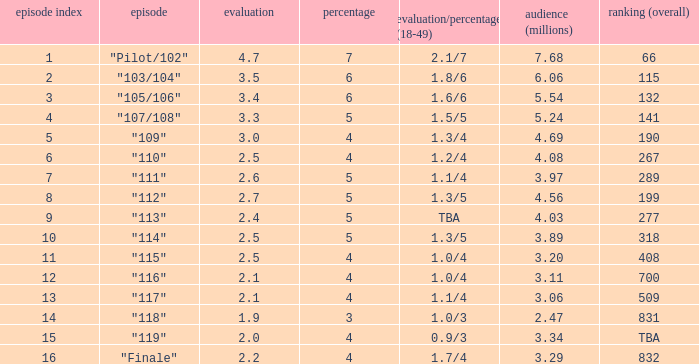WHAT IS THE HIGHEST VIEWERS WITH AN EPISODE LESS THAN 15 AND SHARE LAGER THAN 7? None. 